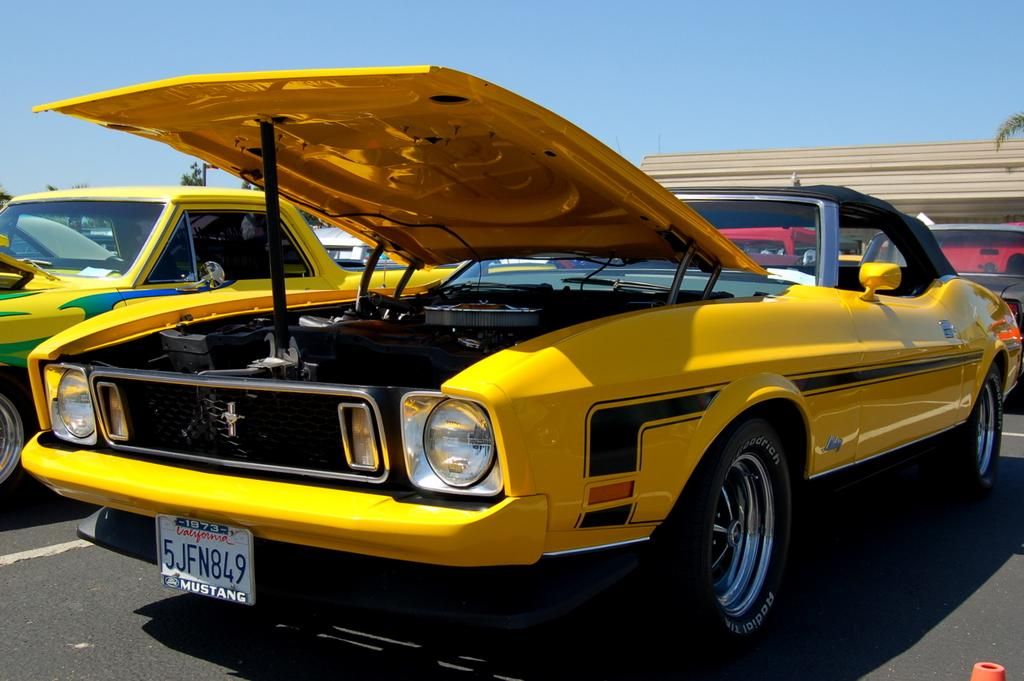<image>
Render a clear and concise summary of the photo. A yellow car with its hood open has a California license plate with a Mustang plate frame. 